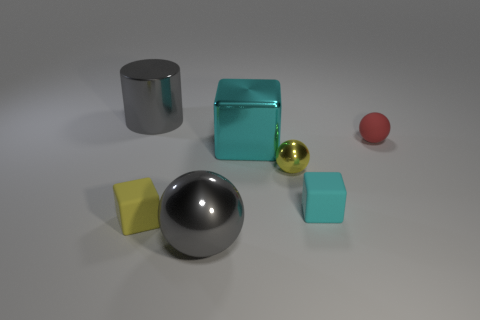There is a yellow rubber thing in front of the cyan matte cube; how many gray balls are to the left of it?
Your answer should be very brief. 0. Do the small ball behind the large cyan cube and the tiny cyan block have the same material?
Offer a very short reply. Yes. There is a cube right of the cube behind the tiny cyan matte object; what is its size?
Provide a succinct answer. Small. There is a gray shiny object that is behind the gray object on the right side of the gray metal thing to the left of the yellow cube; what is its size?
Your response must be concise. Large. Is the shape of the gray metallic thing that is on the right side of the gray shiny cylinder the same as the metal thing on the right side of the cyan metal block?
Your answer should be compact. Yes. Is the size of the shiny sphere in front of the yellow matte block the same as the big gray cylinder?
Provide a succinct answer. Yes. Are the small cube left of the large metal cube and the gray thing behind the tiny cyan rubber thing made of the same material?
Offer a terse response. No. What shape is the large gray metallic object behind the small red rubber object that is behind the yellow metal sphere that is on the right side of the cyan shiny cube?
Offer a very short reply. Cylinder. Does the large gray ball have the same material as the large thing behind the red rubber thing?
Offer a very short reply. Yes. There is a cyan block that is in front of the small sphere that is in front of the red sphere; how many red matte spheres are behind it?
Your answer should be very brief. 1. 